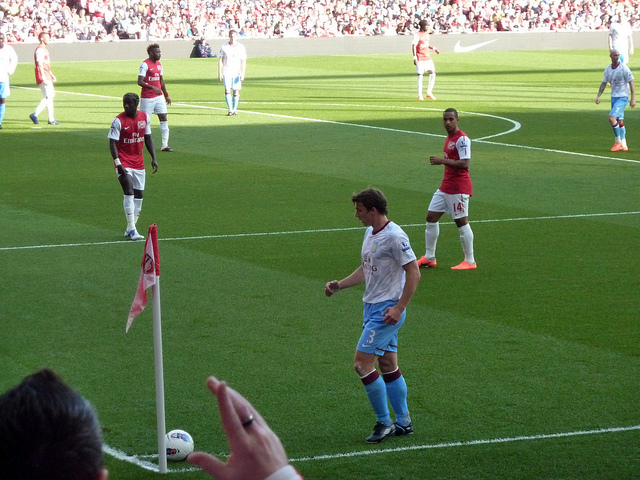<image>Who is going to win? It is unknown who is going to win. It can be either the red team or blue team. Who is going to win? I don't know who is going to win. It can be either the red team or the blue team. 